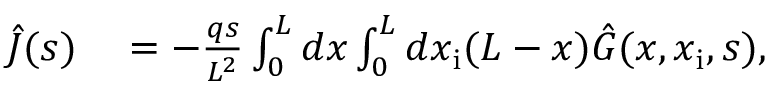Convert formula to latex. <formula><loc_0><loc_0><loc_500><loc_500>\begin{array} { r l } { \hat { J } ( s ) } & = - \frac { q s } { L ^ { 2 } } \int _ { 0 } ^ { L } d x \int _ { 0 } ^ { L } d x _ { i } ( L - x ) \hat { G } ( x , x _ { i } , s ) , } \end{array}</formula> 